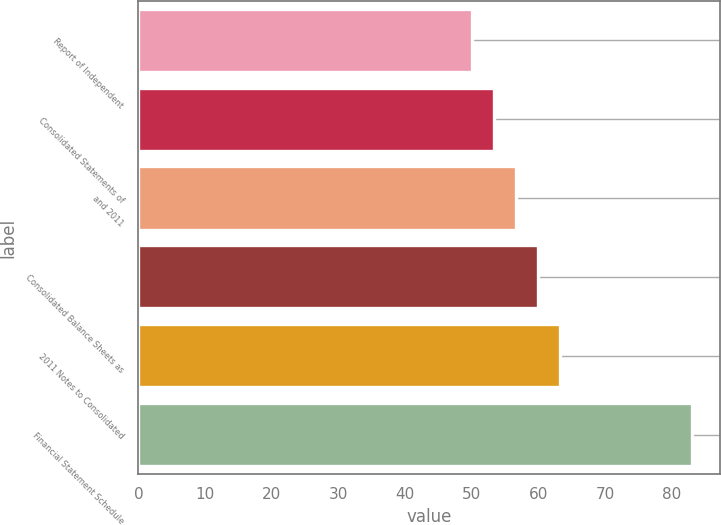Convert chart. <chart><loc_0><loc_0><loc_500><loc_500><bar_chart><fcel>Report of Independent<fcel>Consolidated Statements of<fcel>and 2011<fcel>Consolidated Balance Sheets as<fcel>2011 Notes to Consolidated<fcel>Financial Statement Schedule<nl><fcel>50<fcel>53.3<fcel>56.6<fcel>59.9<fcel>63.2<fcel>83<nl></chart> 